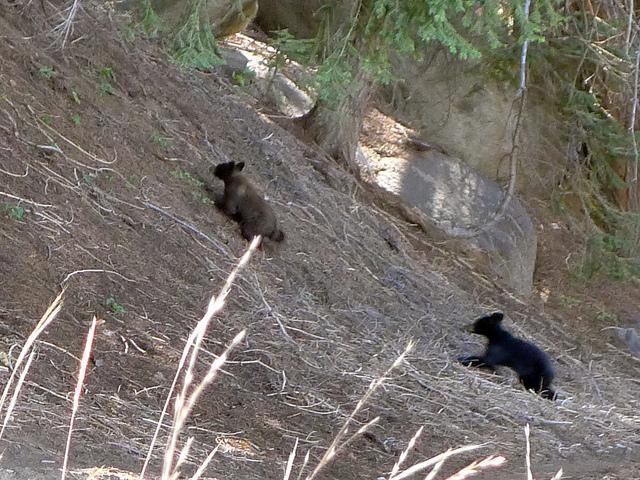How many bears can be seen?
Give a very brief answer. 2. How many zebras are drinking water?
Give a very brief answer. 0. 